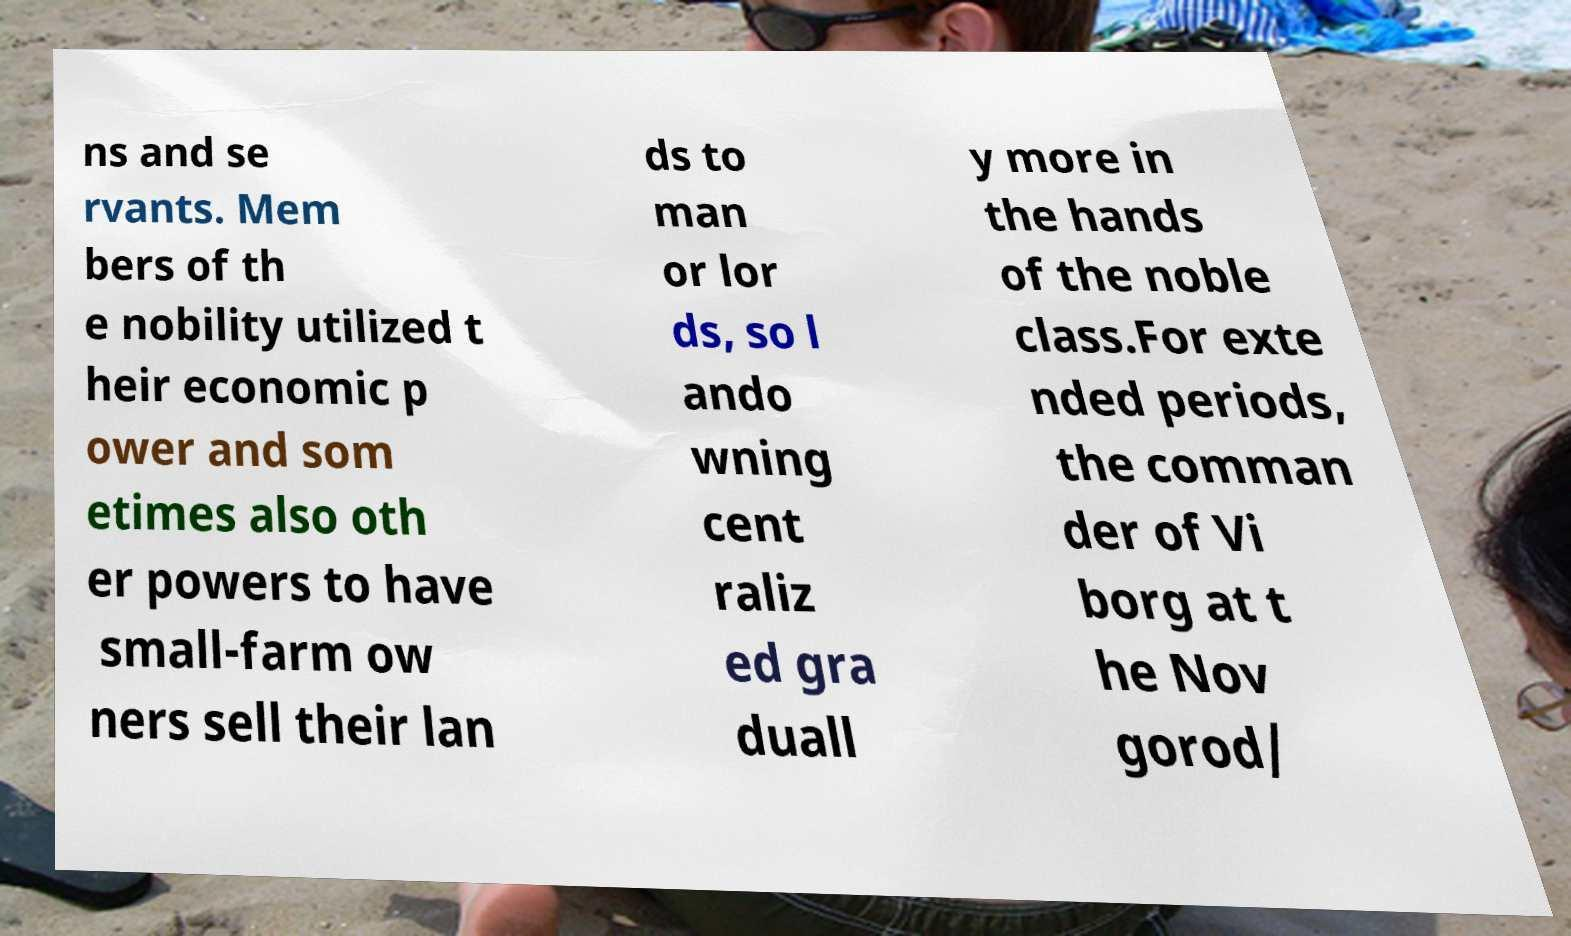Could you extract and type out the text from this image? ns and se rvants. Mem bers of th e nobility utilized t heir economic p ower and som etimes also oth er powers to have small-farm ow ners sell their lan ds to man or lor ds, so l ando wning cent raliz ed gra duall y more in the hands of the noble class.For exte nded periods, the comman der of Vi borg at t he Nov gorod/ 